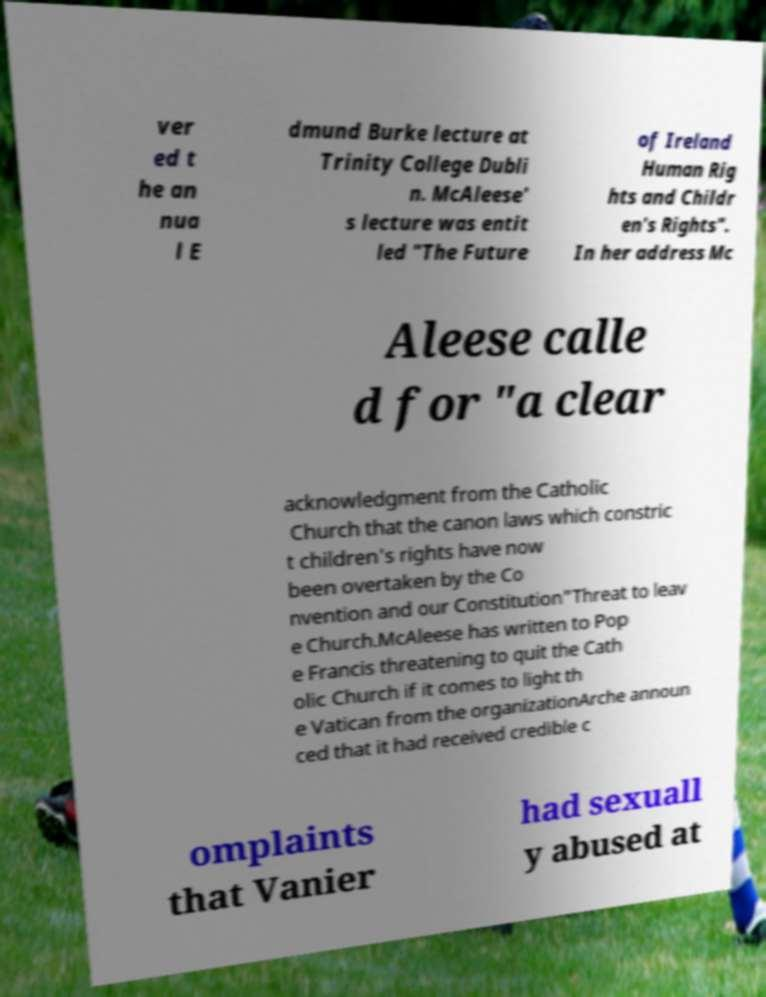Can you read and provide the text displayed in the image?This photo seems to have some interesting text. Can you extract and type it out for me? ver ed t he an nua l E dmund Burke lecture at Trinity College Dubli n. McAleese' s lecture was entit led "The Future of Ireland Human Rig hts and Childr en's Rights". In her address Mc Aleese calle d for "a clear acknowledgment from the Catholic Church that the canon laws which constric t children's rights have now been overtaken by the Co nvention and our Constitution"Threat to leav e Church.McAleese has written to Pop e Francis threatening to quit the Cath olic Church if it comes to light th e Vatican from the organizationArche announ ced that it had received credible c omplaints that Vanier had sexuall y abused at 